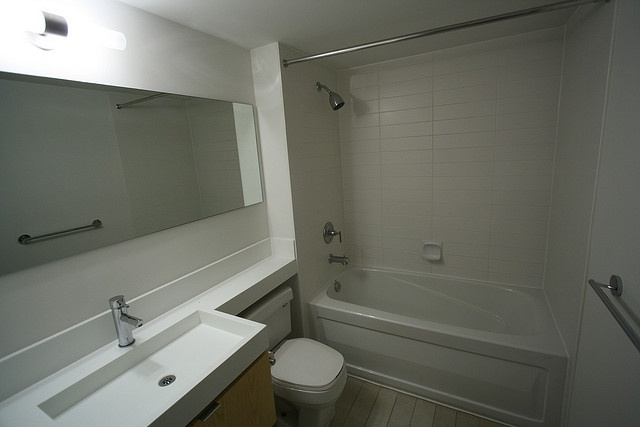Describe the objects in this image and their specific colors. I can see sink in white, darkgray, and lightgray tones and toilet in white, black, and gray tones in this image. 